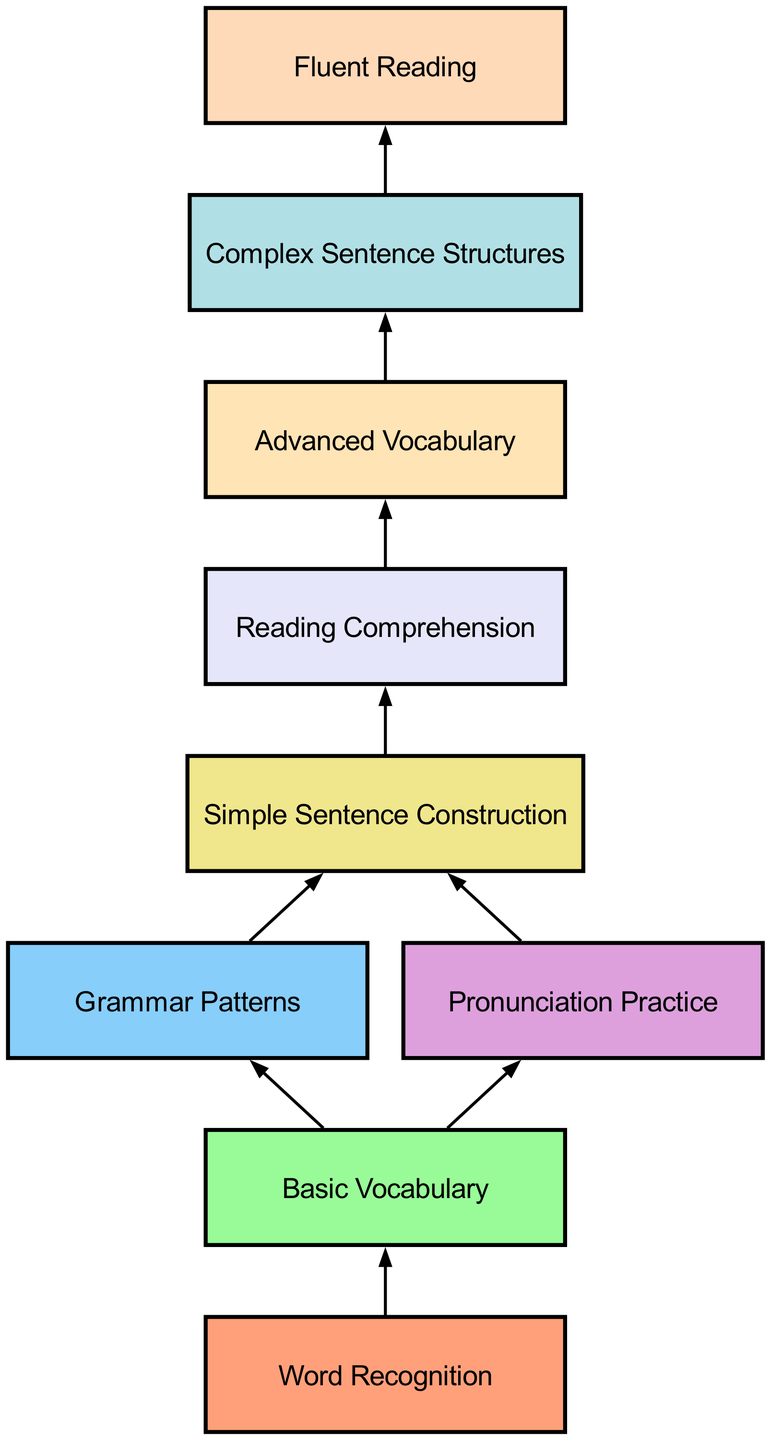What is the first stage of language acquisition in the diagram? The first stage is "Word Recognition," which is the starting point in the flow of the diagram.
Answer: Word Recognition How many nodes are present in the diagram? By counting the individual stages listed in the diagram, we find there are nine distinct nodes from "Word Recognition" to "Fluent Reading."
Answer: 9 What stage follows "Basic Vocabulary"? From the diagram, both "Grammar Patterns" and "Pronunciation Practice" follow the "Basic Vocabulary" stage, indicating multiple pathways in acquisition.
Answer: Grammar Patterns, Pronunciation Practice Which stage is directly connected to "Simple Sentence Construction"? Only one stage is connected to "Simple Sentence Construction," which is "Reading Comprehension". This shows the flow from constructing sentences to understanding text.
Answer: Reading Comprehension What is the last stage of language acquisition according to the diagram? The last stage is "Fluent Reading," which concludes the progression and indicates mastery of reading in the new language.
Answer: Fluent Reading How many connections does the stage "Advanced Vocabulary" have? "Advanced Vocabulary" has one connection leading to "Complex Sentence Structures," showing a single progression from advanced vocabulary to more complex grammar structures.
Answer: 1 What stage includes "Pronunciation Practice"? The stage "Basic Vocabulary" includes "Pronunciation Practice" as one of its connections, highlighting its importance in developing the foundational vocabulary elements.
Answer: Basic Vocabulary What are the two stages that lead to "Simple Sentence Construction"? The stages that lead to "Simple Sentence Construction" are "Grammar Patterns" and "Pronunciation Practice," indicating that both grammar and pronunciation are important for sentence construction.
Answer: Grammar Patterns, Pronunciation Practice 